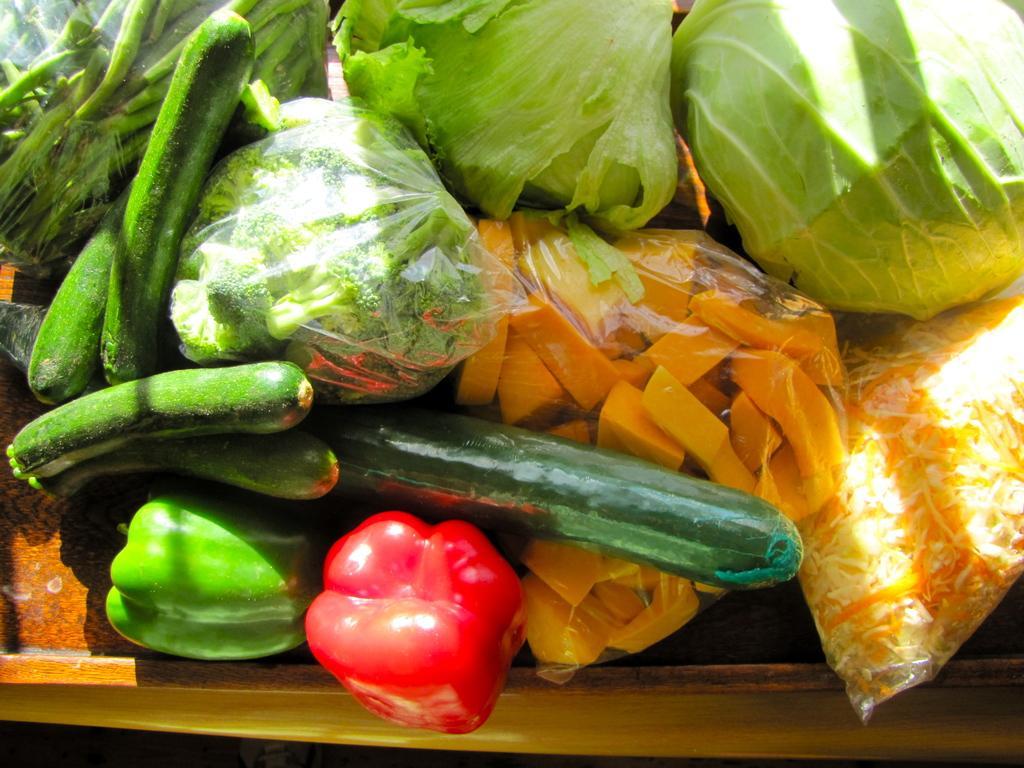In one or two sentences, can you explain what this image depicts? Bottom of the image there is a table, on the table there are some vegetables. 